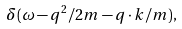Convert formula to latex. <formula><loc_0><loc_0><loc_500><loc_500>\delta ( \omega - q ^ { 2 } / 2 m - q \cdot k / m ) ,</formula> 